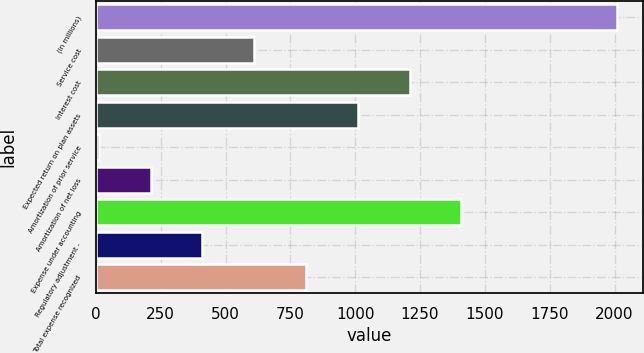<chart> <loc_0><loc_0><loc_500><loc_500><bar_chart><fcel>(in millions)<fcel>Service cost<fcel>Interest cost<fcel>Expected return on plan assets<fcel>Amortization of prior service<fcel>Amortization of net loss<fcel>Expense under accounting<fcel>Regulatory adjustment -<fcel>Total expense recognized<nl><fcel>2009<fcel>610.4<fcel>1209.8<fcel>1010<fcel>11<fcel>210.8<fcel>1409.6<fcel>410.6<fcel>810.2<nl></chart> 